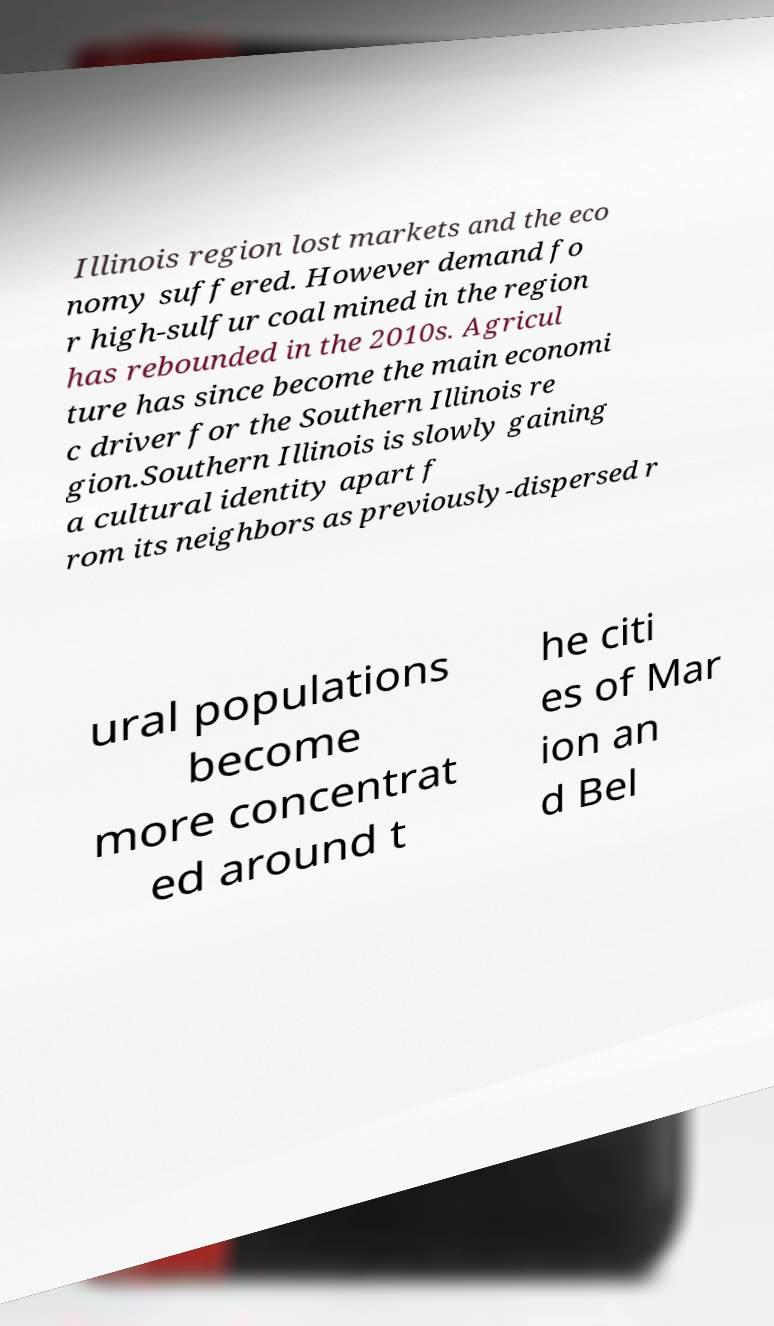There's text embedded in this image that I need extracted. Can you transcribe it verbatim? Illinois region lost markets and the eco nomy suffered. However demand fo r high-sulfur coal mined in the region has rebounded in the 2010s. Agricul ture has since become the main economi c driver for the Southern Illinois re gion.Southern Illinois is slowly gaining a cultural identity apart f rom its neighbors as previously-dispersed r ural populations become more concentrat ed around t he citi es of Mar ion an d Bel 